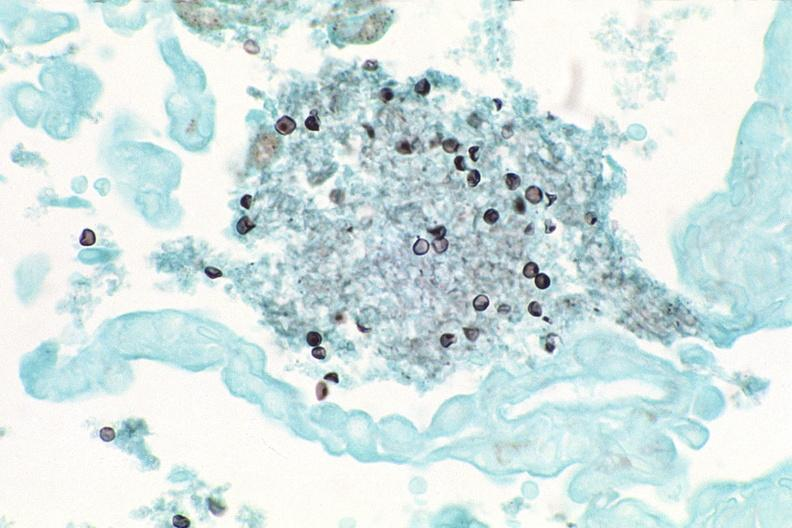what does this image show?
Answer the question using a single word or phrase. Lung 